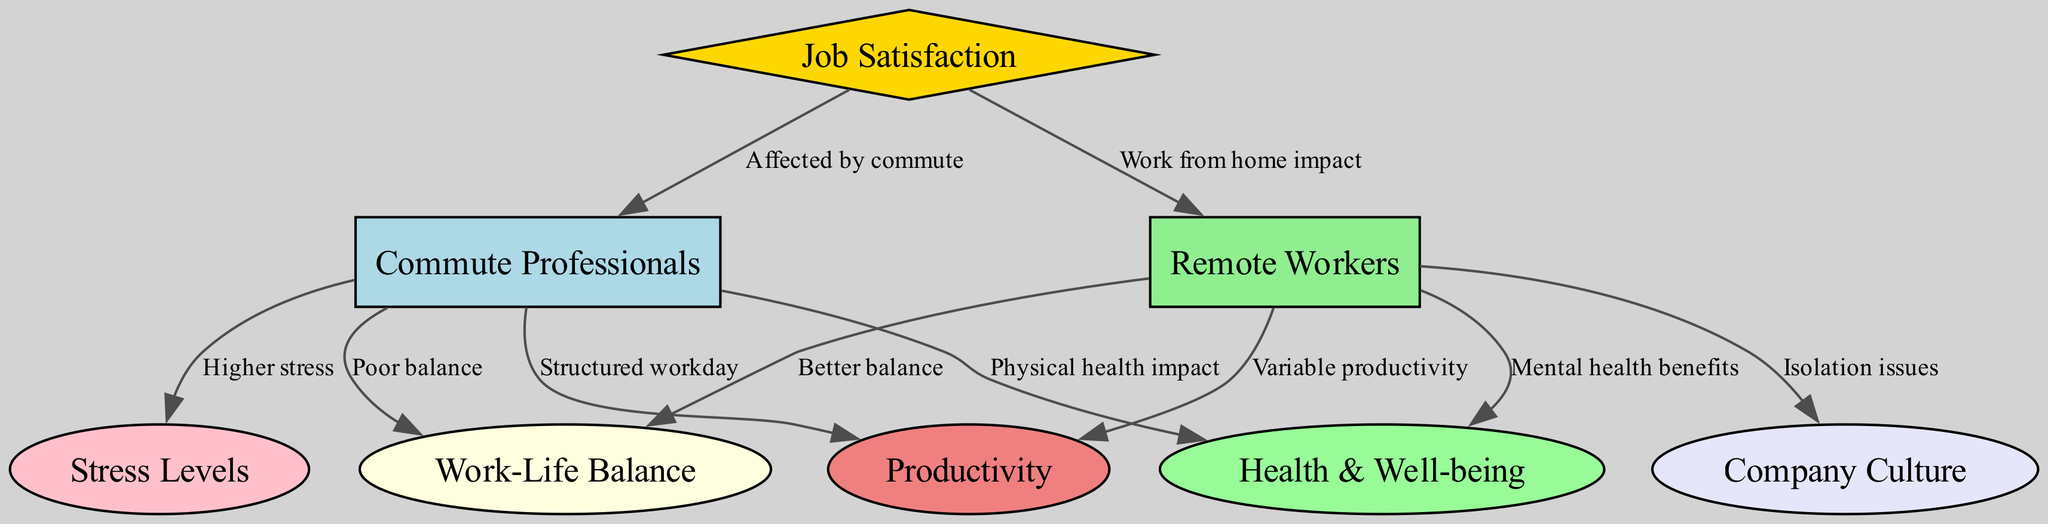What are the two main categories of workers represented in the diagram? The diagram distinguishes between "Commute Professionals" and "Remote Workers" as the two primary categories of workers. These labels can be directly found as nodes in the diagram.
Answer: Commute Professionals, Remote Workers How many nodes are present in the diagram? There are a total of 8 nodes in the diagram, as identified by the nodes listed in the data section.
Answer: 8 What is the relationship that indicates the effect of commuting on job satisfaction? The diagram shows the relationship "Affected by commute" from "Job Satisfaction" to "Commute Professionals," revealing that commuting impacts job satisfaction levels for these professionals.
Answer: Affected by commute Which type of workers is associated with having a better work-life balance? The relationship "Better balance" from "Remote Workers" to "Work-Life Balance" indicates that remote workers are associated with a better work-life balance.
Answer: Remote Workers What does the "Isolation issues" label refer to in the context of remote workers? The label "Isolation issues" indicates a negative aspect linked to "Remote Workers," highlighting challenges such as social isolation that they may experience due to remote work environment.
Answer: Isolation issues How does commute impact stress levels for commuting professionals? The edge labeled "Higher stress" connects "Commute Professionals" to "Stress Levels," implying that commuting increases stress for these workers.
Answer: Higher stress What are remote workers positively associated with regarding health? The relationship "Mental health benefits," connects "Remote Workers" to "Health & Well-being," showing that remote work has positive contributions to mental health for these workers.
Answer: Mental health benefits Which factor is linked to both categories of workers concerning productivity? The diagram presents "Productivity" with connections to both "Commute Professionals" (via "Structured workday") and "Remote Workers" (via "Variable productivity"), indicating that both settings influence productivity in different ways.
Answer: Structured workday, Variable productivity What does the edge "Poor balance" signify about commuting professionals' work-life balance? The edge "Poor balance" connects "Commute Professionals" directly to "Work-Life Balance," suggesting that commute negatively affects the balance between work and personal life for these professionals.
Answer: Poor balance 